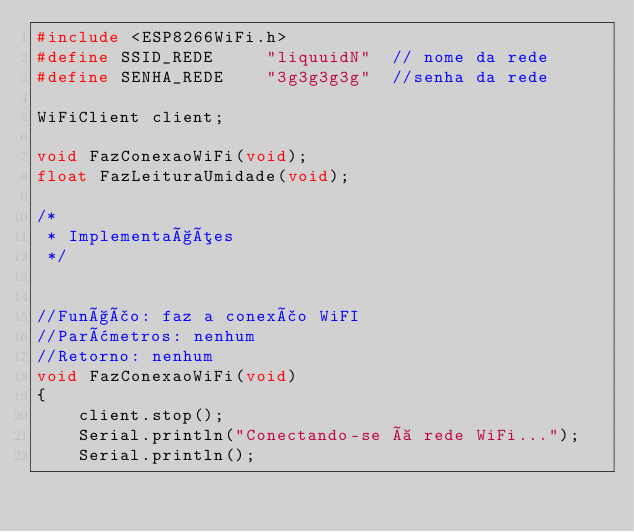Convert code to text. <code><loc_0><loc_0><loc_500><loc_500><_C++_>#include <ESP8266WiFi.h>
#define SSID_REDE     "liquuidN"  // nome da rede
#define SENHA_REDE    "3g3g3g3g"  //senha da rede

WiFiClient client;
 
void FazConexaoWiFi(void);
float FazLeituraUmidade(void);
 
/*
 * Implementações
 */
 
 
//Função: faz a conexão WiFI
//Parâmetros: nenhum
//Retorno: nenhum
void FazConexaoWiFi(void)
{
    client.stop();
    Serial.println("Conectando-se à rede WiFi...");
    Serial.println();  </code> 